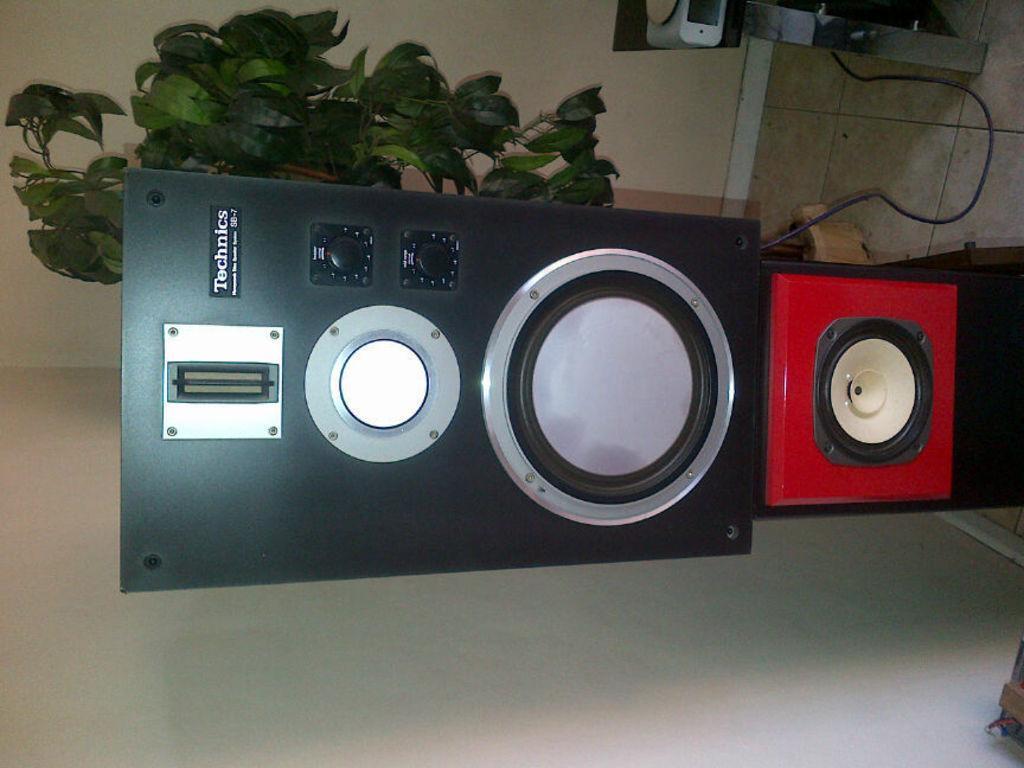Could you give a brief overview of what you see in this image? In this picture I can see black and red color sound speakers. The black color sound speaker is attached to an object with a wire. In the background I can see a plant and wall. I can also see some other object on the floor. 